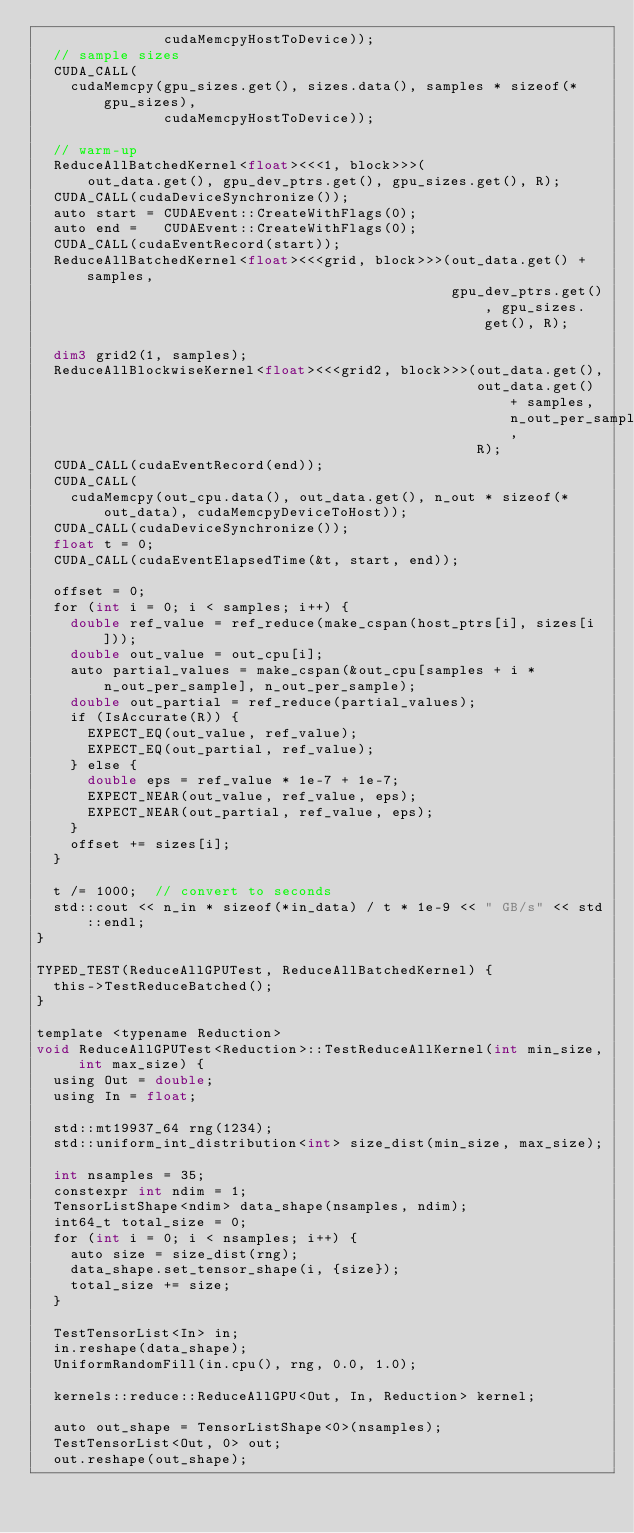Convert code to text. <code><loc_0><loc_0><loc_500><loc_500><_Cuda_>               cudaMemcpyHostToDevice));
  // sample sizes
  CUDA_CALL(
    cudaMemcpy(gpu_sizes.get(), sizes.data(), samples * sizeof(*gpu_sizes),
               cudaMemcpyHostToDevice));

  // warm-up
  ReduceAllBatchedKernel<float><<<1, block>>>(
      out_data.get(), gpu_dev_ptrs.get(), gpu_sizes.get(), R);
  CUDA_CALL(cudaDeviceSynchronize());
  auto start = CUDAEvent::CreateWithFlags(0);
  auto end =   CUDAEvent::CreateWithFlags(0);
  CUDA_CALL(cudaEventRecord(start));
  ReduceAllBatchedKernel<float><<<grid, block>>>(out_data.get() + samples,
                                                 gpu_dev_ptrs.get(), gpu_sizes.get(), R);

  dim3 grid2(1, samples);
  ReduceAllBlockwiseKernel<float><<<grid2, block>>>(out_data.get(),
                                                    out_data.get() + samples, n_out_per_sample,
                                                    R);
  CUDA_CALL(cudaEventRecord(end));
  CUDA_CALL(
    cudaMemcpy(out_cpu.data(), out_data.get(), n_out * sizeof(*out_data), cudaMemcpyDeviceToHost));
  CUDA_CALL(cudaDeviceSynchronize());
  float t = 0;
  CUDA_CALL(cudaEventElapsedTime(&t, start, end));

  offset = 0;
  for (int i = 0; i < samples; i++) {
    double ref_value = ref_reduce(make_cspan(host_ptrs[i], sizes[i]));
    double out_value = out_cpu[i];
    auto partial_values = make_cspan(&out_cpu[samples + i * n_out_per_sample], n_out_per_sample);
    double out_partial = ref_reduce(partial_values);
    if (IsAccurate(R)) {
      EXPECT_EQ(out_value, ref_value);
      EXPECT_EQ(out_partial, ref_value);
    } else {
      double eps = ref_value * 1e-7 + 1e-7;
      EXPECT_NEAR(out_value, ref_value, eps);
      EXPECT_NEAR(out_partial, ref_value, eps);
    }
    offset += sizes[i];
  }

  t /= 1000;  // convert to seconds
  std::cout << n_in * sizeof(*in_data) / t * 1e-9 << " GB/s" << std::endl;
}

TYPED_TEST(ReduceAllGPUTest, ReduceAllBatchedKernel) {
  this->TestReduceBatched();
}

template <typename Reduction>
void ReduceAllGPUTest<Reduction>::TestReduceAllKernel(int min_size, int max_size) {
  using Out = double;
  using In = float;

  std::mt19937_64 rng(1234);
  std::uniform_int_distribution<int> size_dist(min_size, max_size);

  int nsamples = 35;
  constexpr int ndim = 1;
  TensorListShape<ndim> data_shape(nsamples, ndim);
  int64_t total_size = 0;
  for (int i = 0; i < nsamples; i++) {
    auto size = size_dist(rng);
    data_shape.set_tensor_shape(i, {size});
    total_size += size;
  }

  TestTensorList<In> in;
  in.reshape(data_shape);
  UniformRandomFill(in.cpu(), rng, 0.0, 1.0);

  kernels::reduce::ReduceAllGPU<Out, In, Reduction> kernel;

  auto out_shape = TensorListShape<0>(nsamples);
  TestTensorList<Out, 0> out;
  out.reshape(out_shape);
</code> 